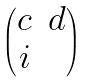<formula> <loc_0><loc_0><loc_500><loc_500>\begin{pmatrix} c & d \\ i & \end{pmatrix}</formula> 